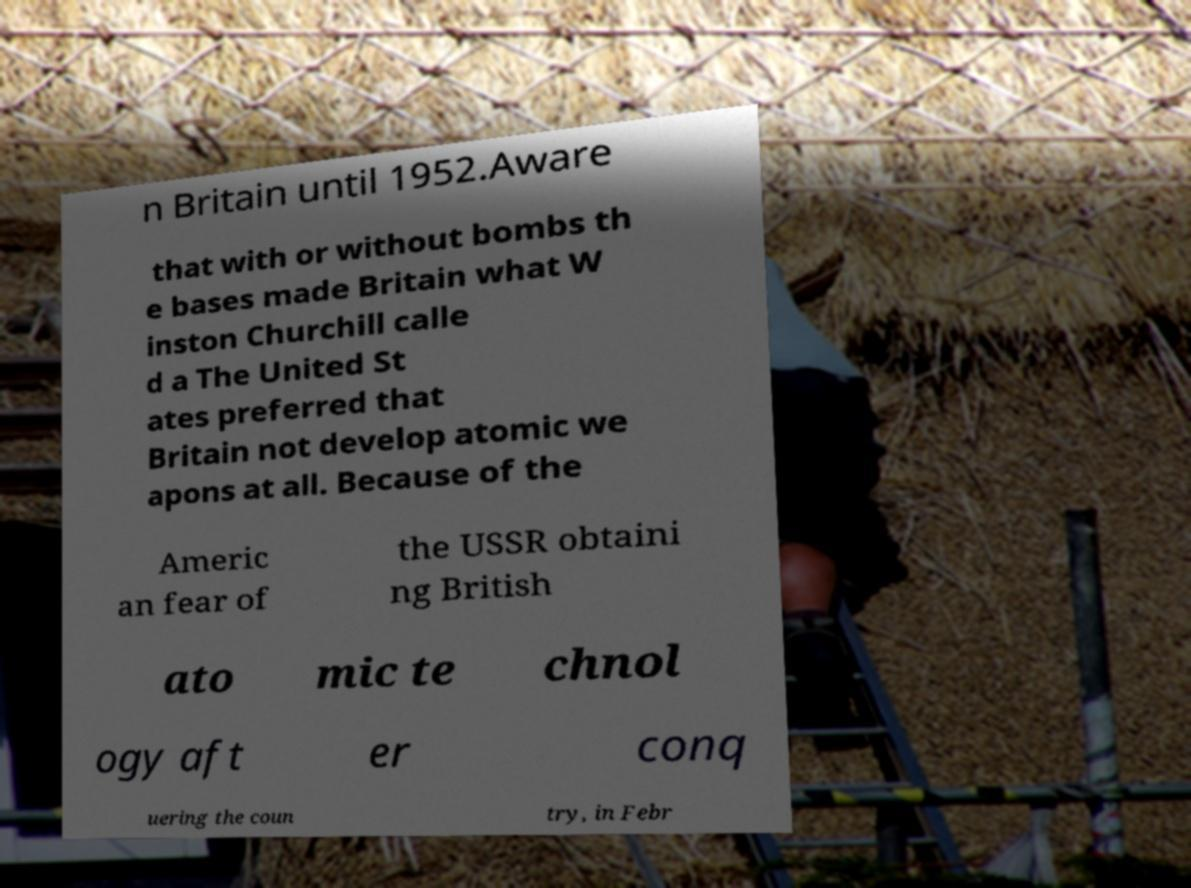For documentation purposes, I need the text within this image transcribed. Could you provide that? n Britain until 1952.Aware that with or without bombs th e bases made Britain what W inston Churchill calle d a The United St ates preferred that Britain not develop atomic we apons at all. Because of the Americ an fear of the USSR obtaini ng British ato mic te chnol ogy aft er conq uering the coun try, in Febr 